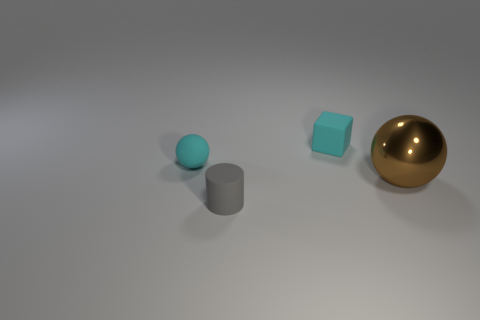What is the object on the right side of the tiny cube made of? The object on the right side of the tiny cube appears to be a sphere that has a reflective surface, which suggests it could be made of a polished metal, possibly gold or brass due to its golden color. 